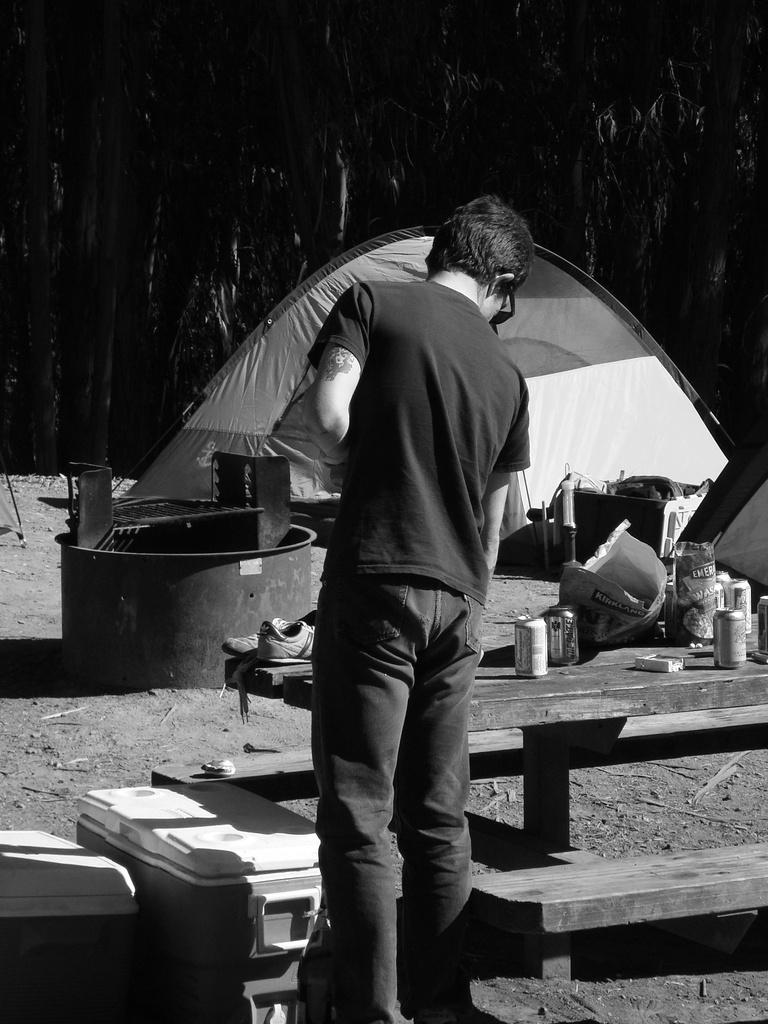Could you give a brief overview of what you see in this image? It is a black and white image, there is a man and there is a table in front of him, on the table there are many objects and beside the table there are some boxes, there is some architecture on the ground in front of those boxes and in the background there is a tent and behind that there are many trees. 